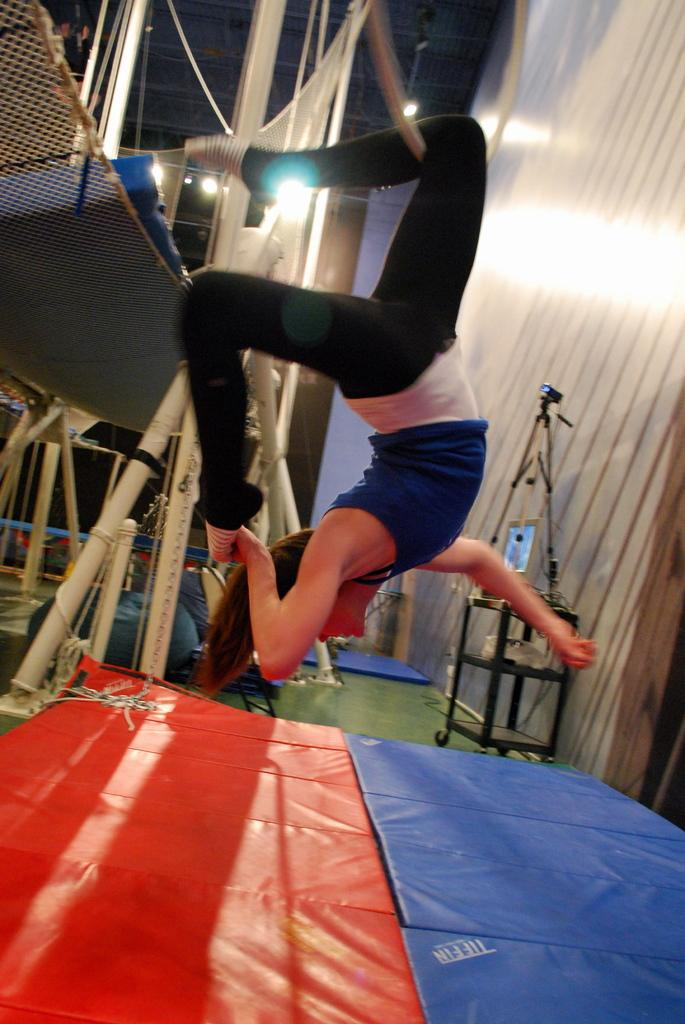Who is the main subject in the image? There is a woman in the image. What is the woman doing in the image? The woman is jumping. What is present at the bottom of the image? There are mats at the bottom of the image. What can be seen in the background of the image? There are lights, a net, and a wall in the background of the image. What type of sheet is draped over the vase in the image? There is no sheet or vase present in the image. How does the woman stretch her muscles before jumping in the image? The image does not show the woman stretching her muscles before jumping. 